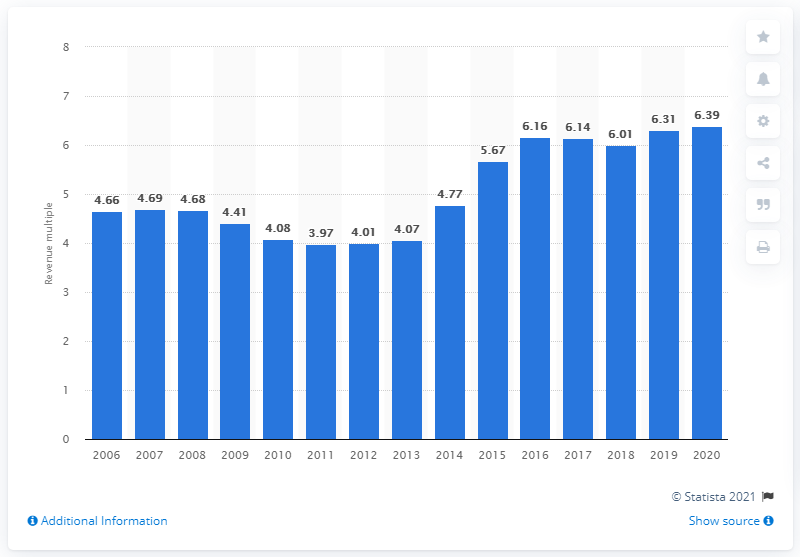Identify some key points in this picture. In 2020, the average revenue multiple of an NFL franchise was 6.39. 